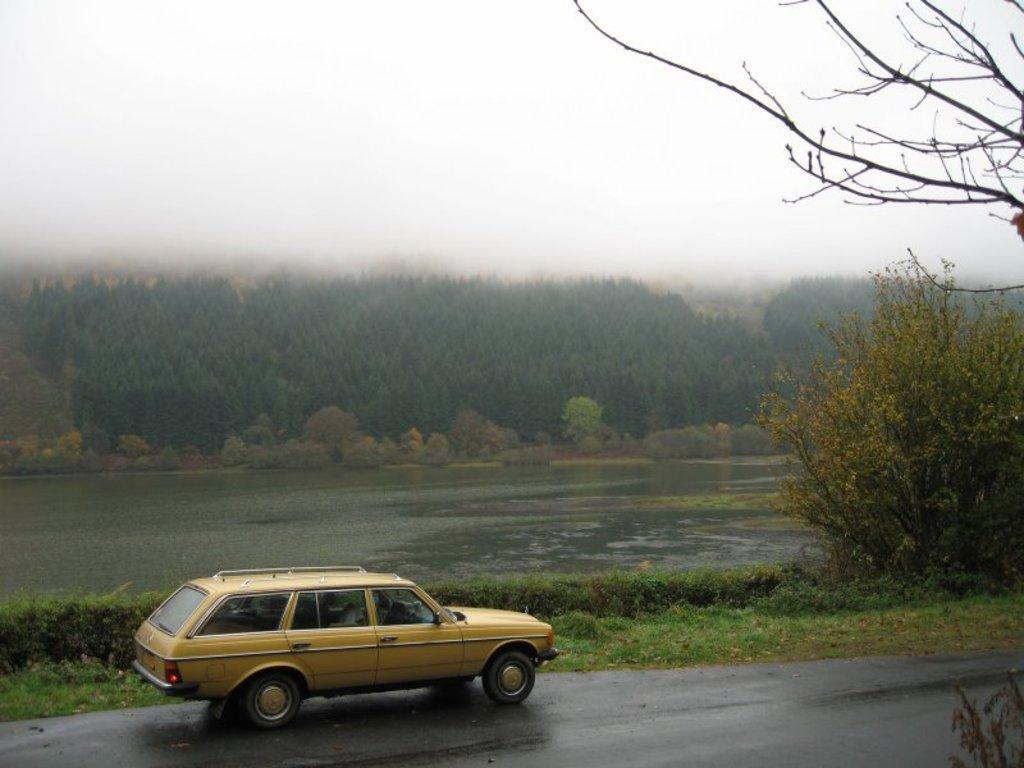What is the main subject of the image? There is a car on the road in the image. What can be seen in the background of the image? There are trees, plants, and water visible in the background of the image. What is visible at the top of the image? The sky is visible at the top of the image. How many babies are sitting in the car in the image? There are no babies present in the image; it features a car on the road with no visible occupants. What type of thread is being used to hold the water in the background? There is no thread visible in the image, and the water is not being held by any visible means. 